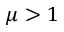<formula> <loc_0><loc_0><loc_500><loc_500>\mu > 1</formula> 